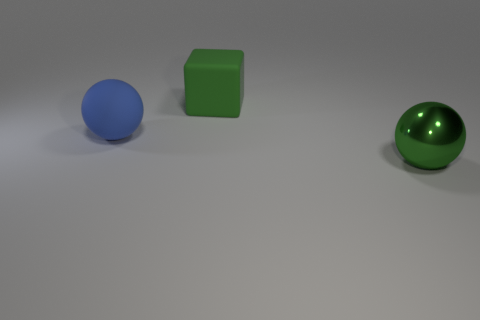Is there anything else that has the same material as the big green sphere?
Your answer should be compact. No. How many other things are there of the same color as the block?
Your answer should be compact. 1. What number of blue objects are either large rubber spheres or large spheres?
Your answer should be very brief. 1. There is a thing behind the blue object; what is it made of?
Make the answer very short. Rubber. Does the green thing in front of the big green block have the same material as the green cube?
Give a very brief answer. No. What is the shape of the large green rubber object?
Your answer should be compact. Cube. There is a green thing that is behind the sphere that is right of the big block; how many rubber objects are in front of it?
Provide a short and direct response. 1. What number of other things are the same material as the green cube?
Make the answer very short. 1. There is a green thing that is the same size as the shiny sphere; what material is it?
Provide a short and direct response. Rubber. Is the color of the big thing that is to the left of the matte cube the same as the large block behind the green metallic sphere?
Provide a succinct answer. No. 